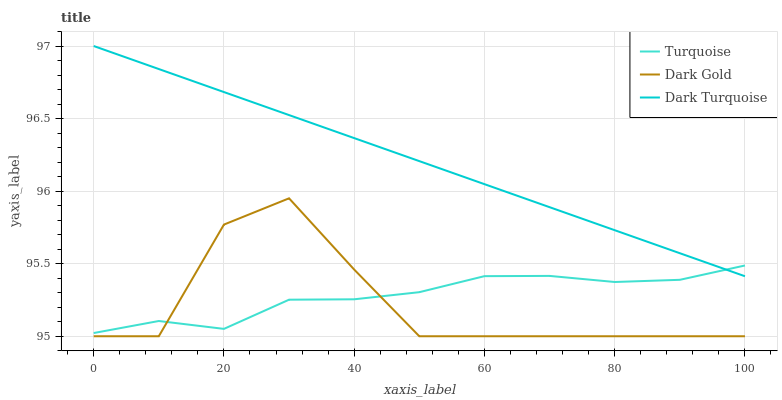Does Dark Gold have the minimum area under the curve?
Answer yes or no. Yes. Does Dark Turquoise have the maximum area under the curve?
Answer yes or no. Yes. Does Turquoise have the minimum area under the curve?
Answer yes or no. No. Does Turquoise have the maximum area under the curve?
Answer yes or no. No. Is Dark Turquoise the smoothest?
Answer yes or no. Yes. Is Dark Gold the roughest?
Answer yes or no. Yes. Is Turquoise the smoothest?
Answer yes or no. No. Is Turquoise the roughest?
Answer yes or no. No. Does Dark Gold have the lowest value?
Answer yes or no. Yes. Does Turquoise have the lowest value?
Answer yes or no. No. Does Dark Turquoise have the highest value?
Answer yes or no. Yes. Does Dark Gold have the highest value?
Answer yes or no. No. Is Dark Gold less than Dark Turquoise?
Answer yes or no. Yes. Is Dark Turquoise greater than Dark Gold?
Answer yes or no. Yes. Does Turquoise intersect Dark Turquoise?
Answer yes or no. Yes. Is Turquoise less than Dark Turquoise?
Answer yes or no. No. Is Turquoise greater than Dark Turquoise?
Answer yes or no. No. Does Dark Gold intersect Dark Turquoise?
Answer yes or no. No. 